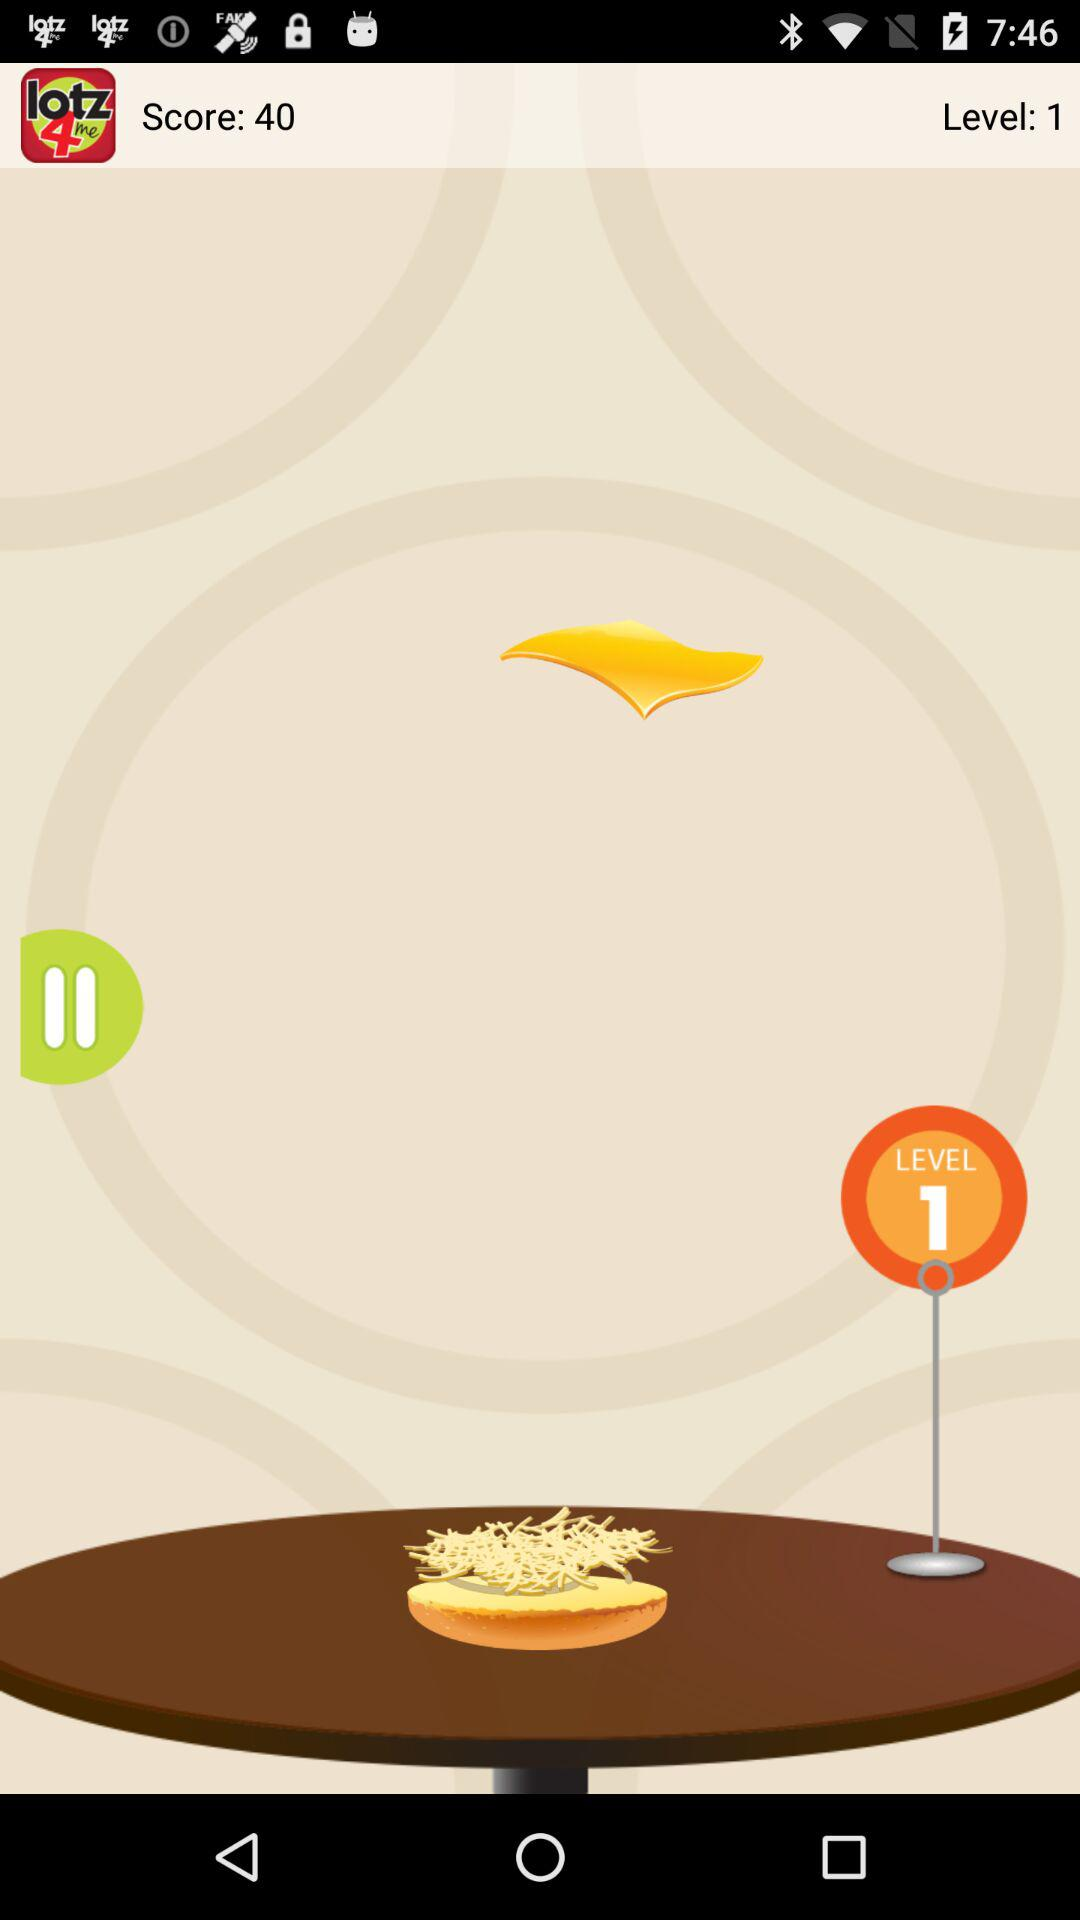What is the score? The score is 40. 